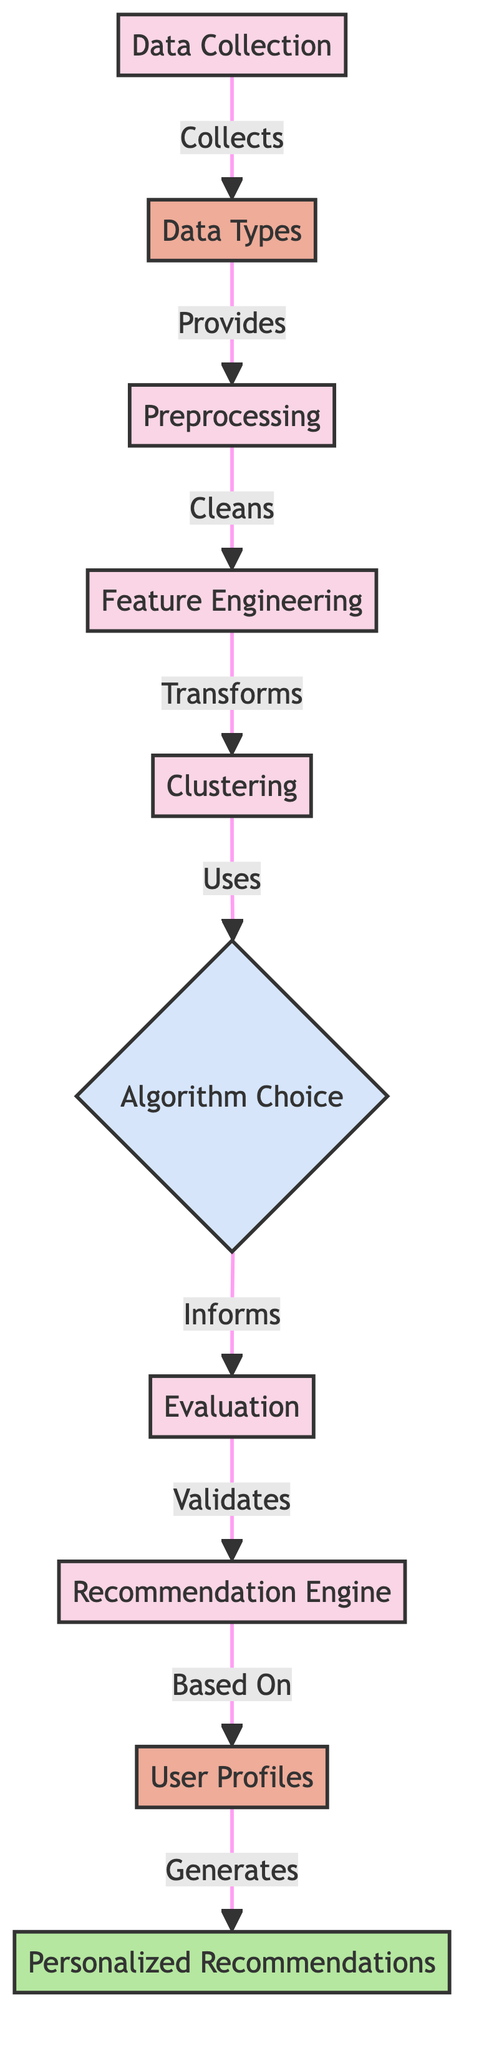What process follows data collection? After the data collection phase, the next step indicated in the diagram is "Data Types," which processes the data collected.
Answer: Data Types How many processes are involved in this diagram? By counting the process nodes, we find there are six processes: Data Collection, Preprocessing, Feature Engineering, Clustering, Evaluation, and Recommendation Engine.
Answer: Six What is the output of the recommendation engine? The output of the recommendation engine, as specified in the diagram, is "Personalized Recommendations," which are based on user profiles.
Answer: Personalized Recommendations Which process directly uses algorithm choice? The "Clustering" process is the one that directly uses "Algorithm Choice," as indicated by the flow from clustering towards algorithm choice in the diagram.
Answer: Clustering What type of data is used in generating personalized recommendations? The diagram illustrates that "User Profiles" are the specific type of data used to generate personalized recommendations.
Answer: User Profiles What comes after feature engineering in the process? Following feature engineering in the flow of the diagram is "Clustering," which indicates that once features are engineered, they are passed to the clustering step.
Answer: Clustering How is the recommendation engine validated? The validation of the recommendation engine is carried out through the "Evaluation" step, as shown by the arrow connecting these two processes in the diagram.
Answer: Evaluation Which node provides data to the preprocessing step? The step "Data Types" provides the necessary data to the "Preprocessing" step, as shown by the directional flow in the diagram.
Answer: Data Types What decision is indicated in the diagram? The node for "Algorithm Choice" is the decision point in the diagram, determining which algorithm will be used in the clustering process.
Answer: Algorithm Choice 